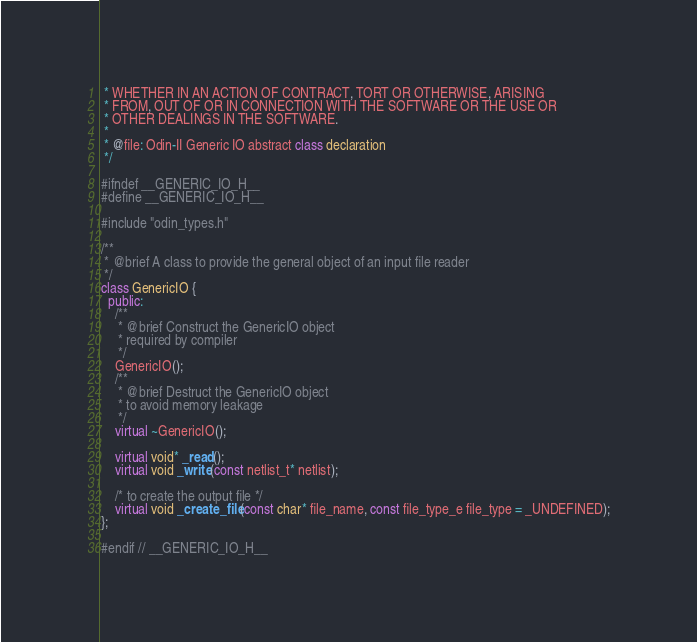Convert code to text. <code><loc_0><loc_0><loc_500><loc_500><_C++_> * WHETHER IN AN ACTION OF CONTRACT, TORT OR OTHERWISE, ARISING
 * FROM, OUT OF OR IN CONNECTION WITH THE SOFTWARE OR THE USE OR
 * OTHER DEALINGS IN THE SOFTWARE.
 *
 * @file: Odin-II Generic IO abstract class declaration
 */

#ifndef __GENERIC_IO_H__
#define __GENERIC_IO_H__

#include "odin_types.h"

/**
 * @brief A class to provide the general object of an input file reader
 */
class GenericIO {
  public:
    /**
     * @brief Construct the GenericIO object
     * required by compiler
     */
    GenericIO();
    /**
     * @brief Destruct the GenericIO object
     * to avoid memory leakage
     */
    virtual ~GenericIO();

    virtual void* _read();
    virtual void _write(const netlist_t* netlist);

    /* to create the output file */
    virtual void _create_file(const char* file_name, const file_type_e file_type = _UNDEFINED);
};

#endif // __GENERIC_IO_H__
</code> 